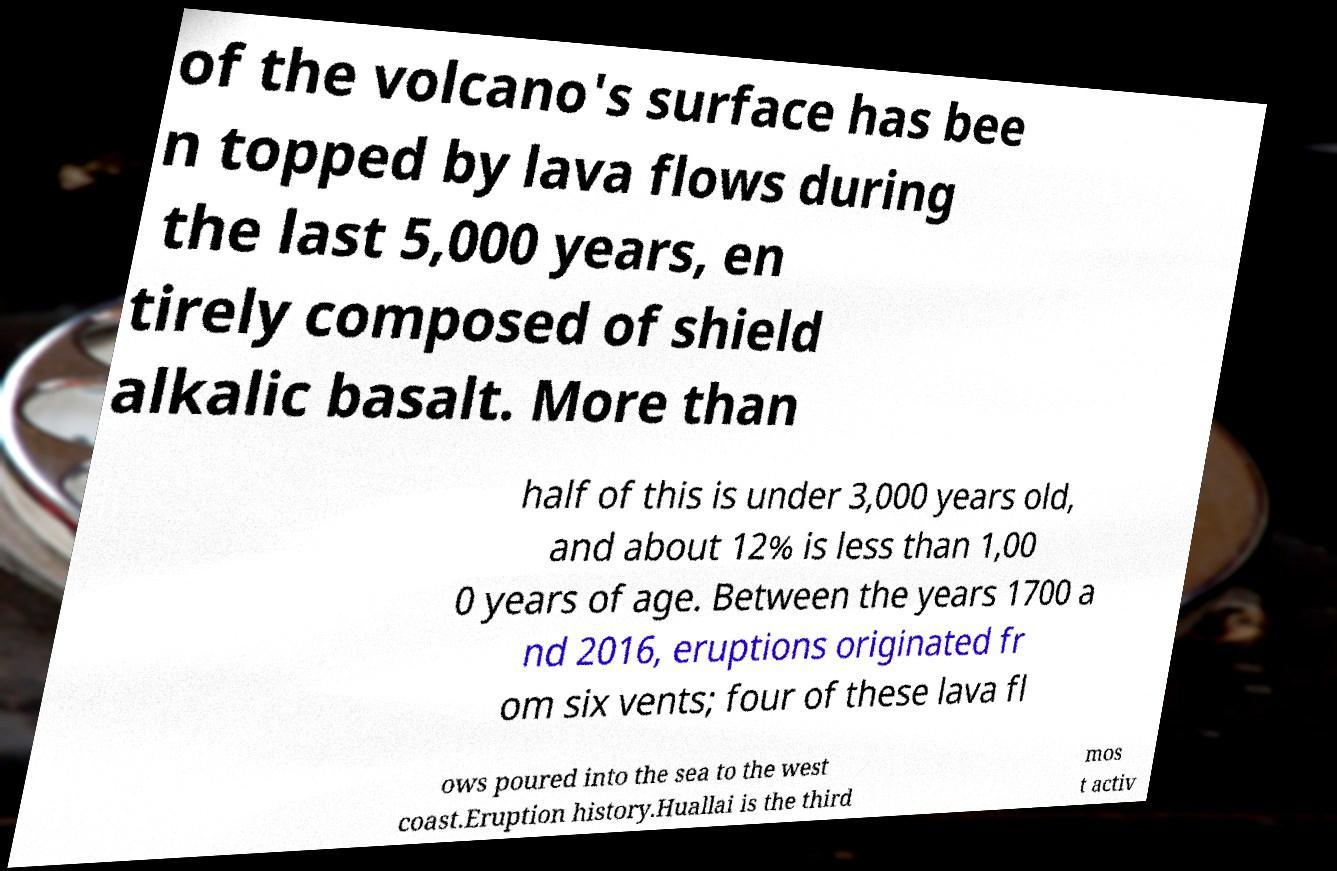Can you accurately transcribe the text from the provided image for me? of the volcano's surface has bee n topped by lava flows during the last 5,000 years, en tirely composed of shield alkalic basalt. More than half of this is under 3,000 years old, and about 12% is less than 1,00 0 years of age. Between the years 1700 a nd 2016, eruptions originated fr om six vents; four of these lava fl ows poured into the sea to the west coast.Eruption history.Huallai is the third mos t activ 